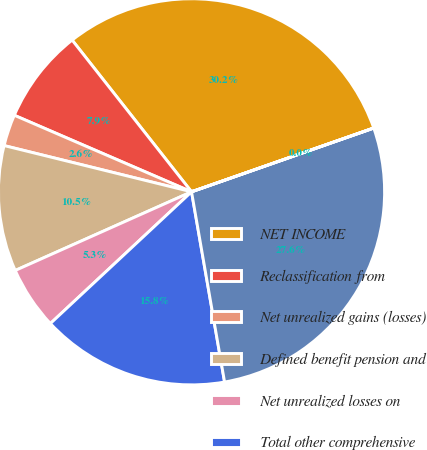<chart> <loc_0><loc_0><loc_500><loc_500><pie_chart><fcel>NET INCOME<fcel>Reclassification from<fcel>Net unrealized gains (losses)<fcel>Defined benefit pension and<fcel>Net unrealized losses on<fcel>Total other comprehensive<fcel>COMPREHENSIVE INCOME<fcel>LESS COMPREHENSIVE INCOME<nl><fcel>30.25%<fcel>7.9%<fcel>2.64%<fcel>10.53%<fcel>5.27%<fcel>15.79%<fcel>27.62%<fcel>0.01%<nl></chart> 